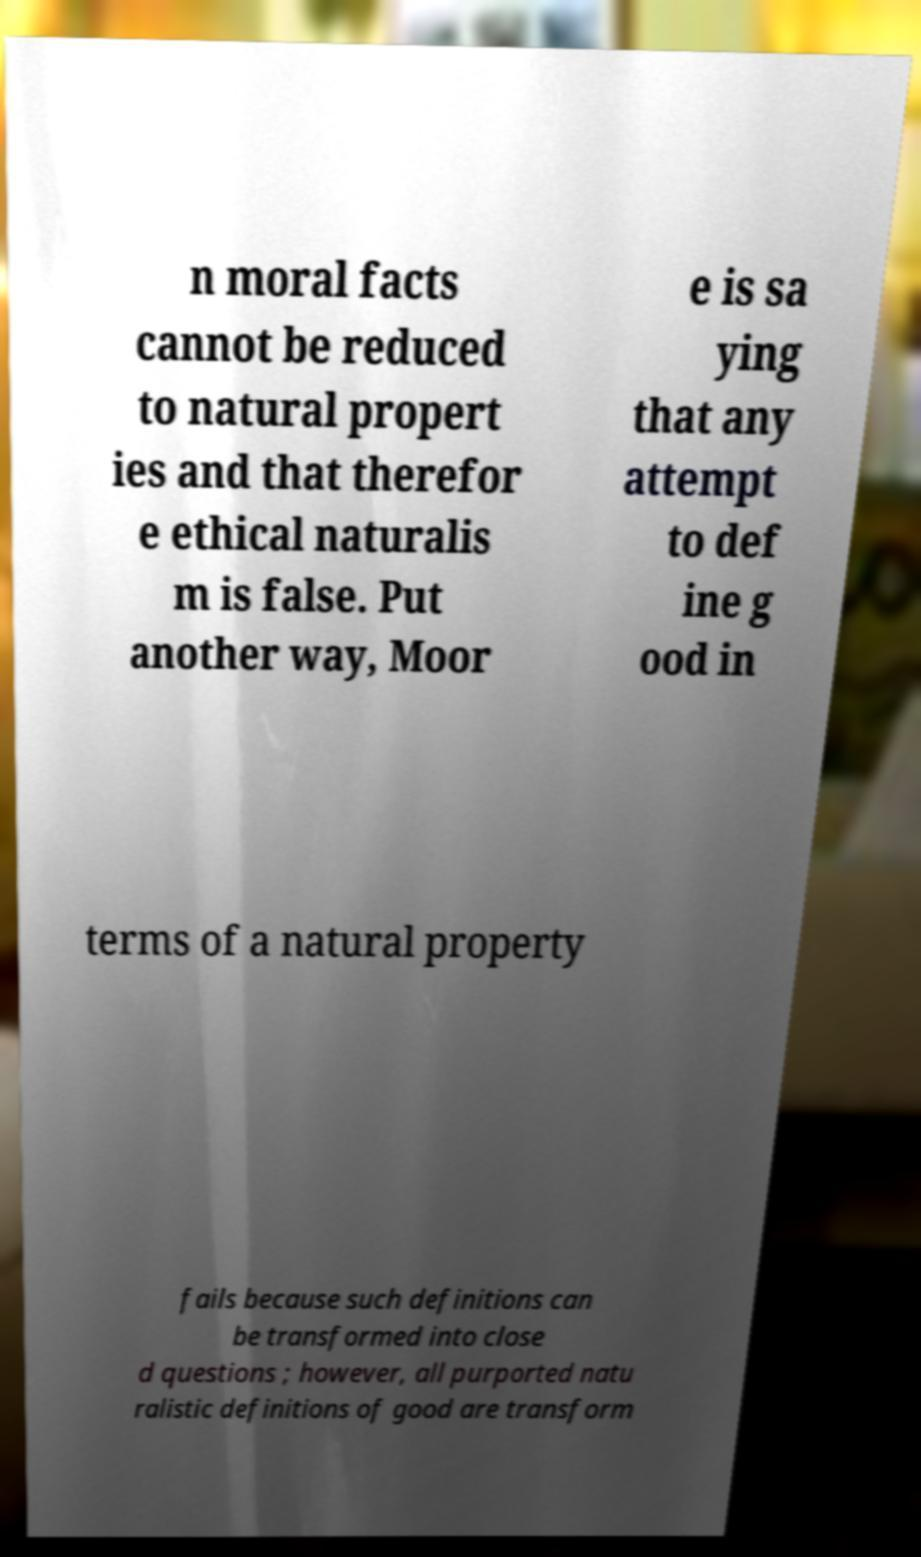Could you assist in decoding the text presented in this image and type it out clearly? n moral facts cannot be reduced to natural propert ies and that therefor e ethical naturalis m is false. Put another way, Moor e is sa ying that any attempt to def ine g ood in terms of a natural property fails because such definitions can be transformed into close d questions ; however, all purported natu ralistic definitions of good are transform 